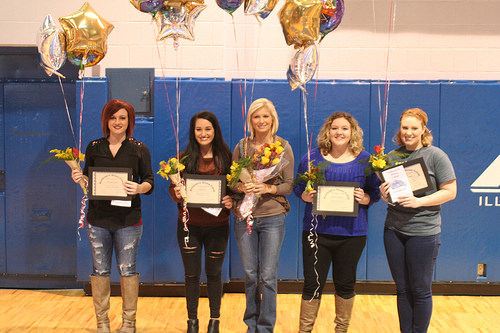<image>
Is the woman on the floor? Yes. Looking at the image, I can see the woman is positioned on top of the floor, with the floor providing support. Is there a black hair on the woman? No. The black hair is not positioned on the woman. They may be near each other, but the black hair is not supported by or resting on top of the woman. 